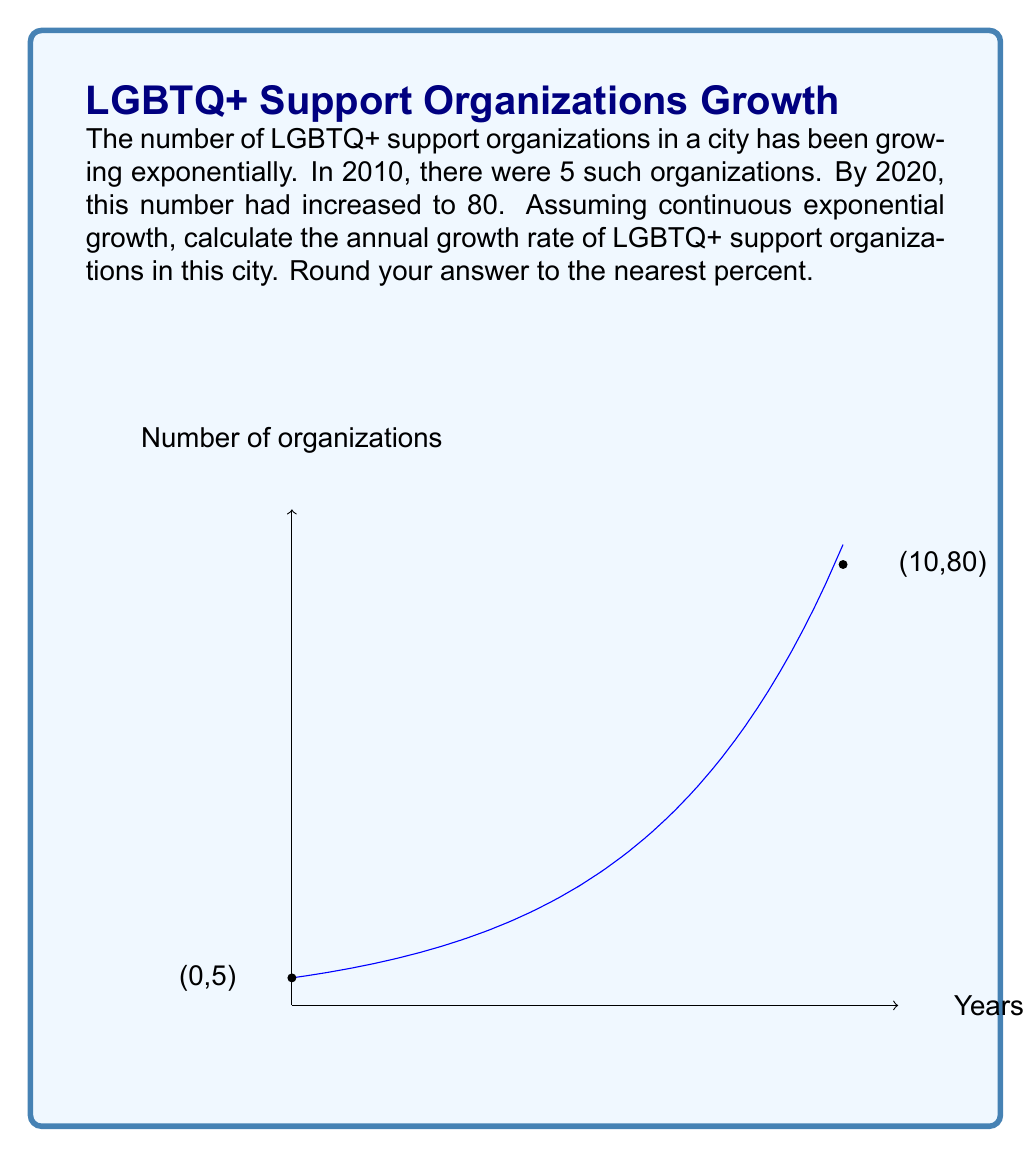Show me your answer to this math problem. Let's approach this step-by-step:

1) The formula for continuous exponential growth is:

   $$A(t) = A_0 e^{rt}$$

   where $A(t)$ is the amount at time $t$, $A_0$ is the initial amount, $r$ is the growth rate, and $t$ is the time.

2) We know:
   - Initial amount in 2010: $A_0 = 5$
   - Amount after 10 years in 2020: $A(10) = 80$
   - Time period: $t = 10$ years

3) Let's plug these into our formula:

   $$80 = 5e^{10r}$$

4) Divide both sides by 5:

   $$16 = e^{10r}$$

5) Take the natural log of both sides:

   $$\ln(16) = 10r$$

6) Solve for $r$:

   $$r = \frac{\ln(16)}{10} \approx 0.2817$$

7) To convert this to a percentage, multiply by 100:

   $$0.2817 * 100 \approx 28.17\%$$

8) Rounding to the nearest percent:

   $$28.17\% \approx 28\%$$

Therefore, the annual growth rate is approximately 28%.
Answer: 28% 